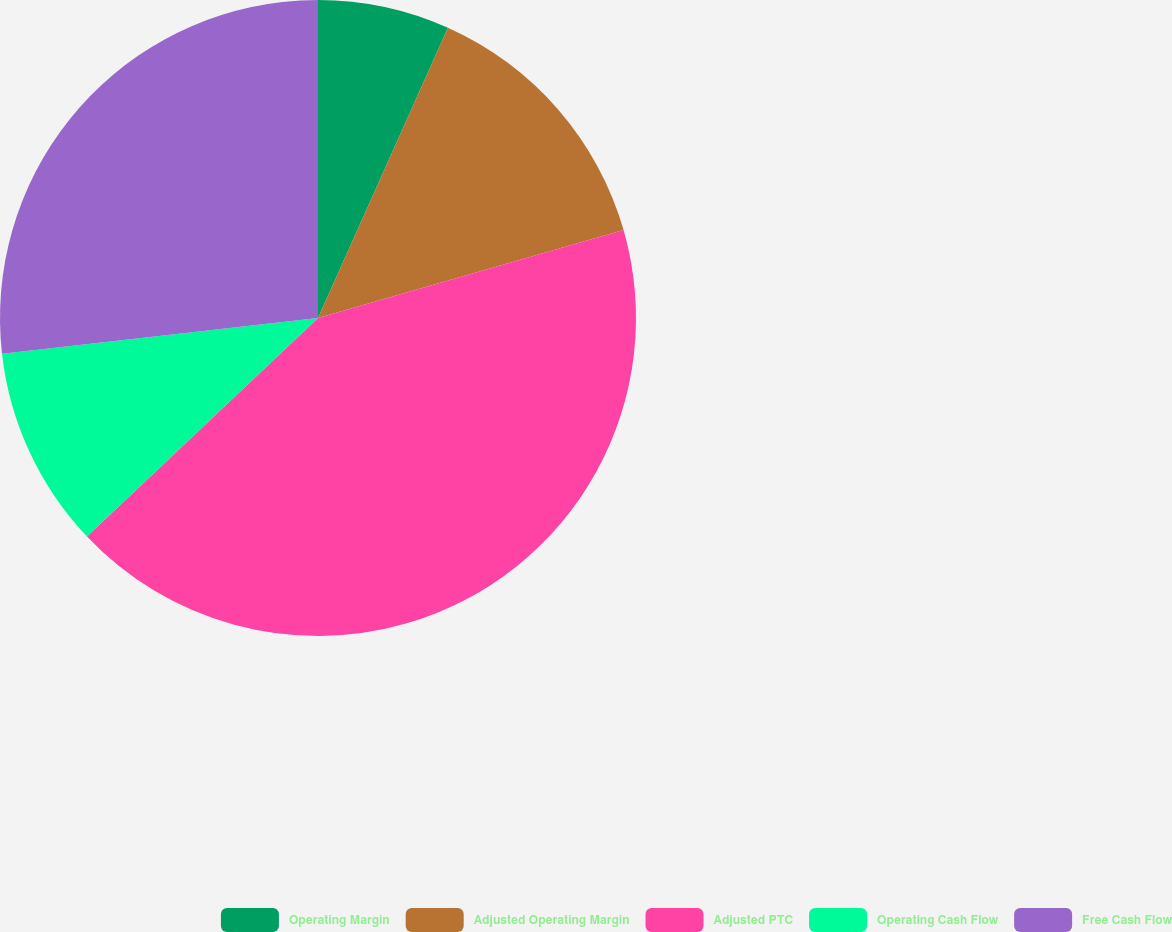<chart> <loc_0><loc_0><loc_500><loc_500><pie_chart><fcel>Operating Margin<fcel>Adjusted Operating Margin<fcel>Adjusted PTC<fcel>Operating Cash Flow<fcel>Free Cash Flow<nl><fcel>6.7%<fcel>13.84%<fcel>42.41%<fcel>10.27%<fcel>26.79%<nl></chart> 